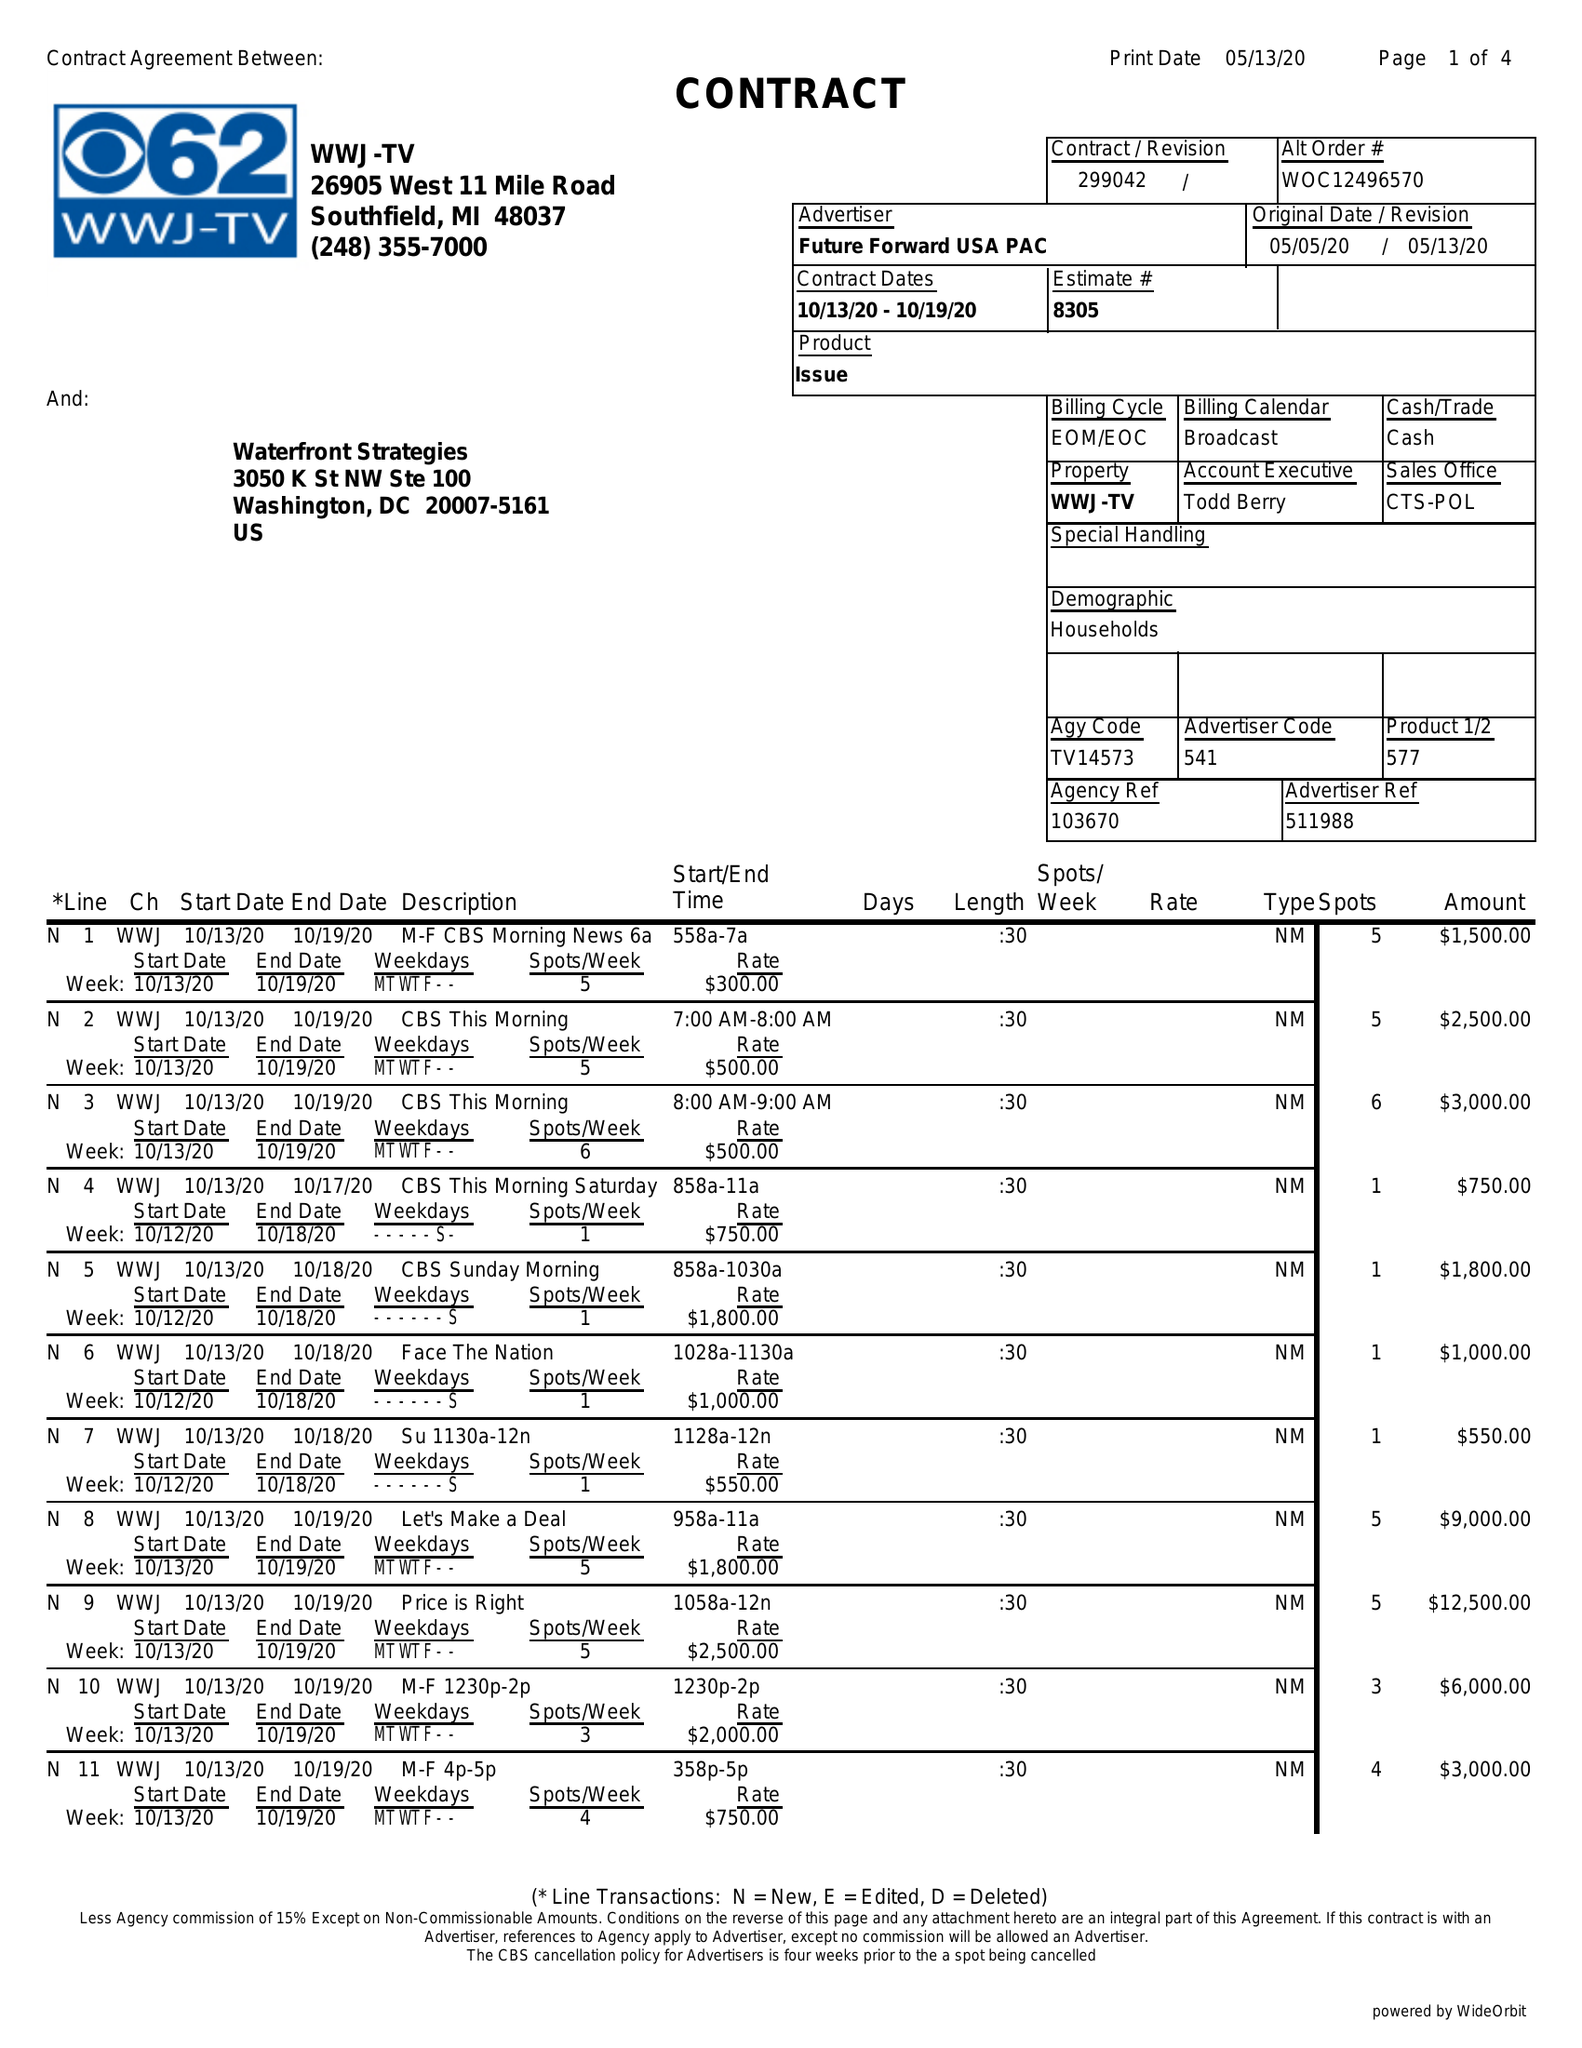What is the value for the advertiser?
Answer the question using a single word or phrase. FUTURE FORWARD USA PAC 